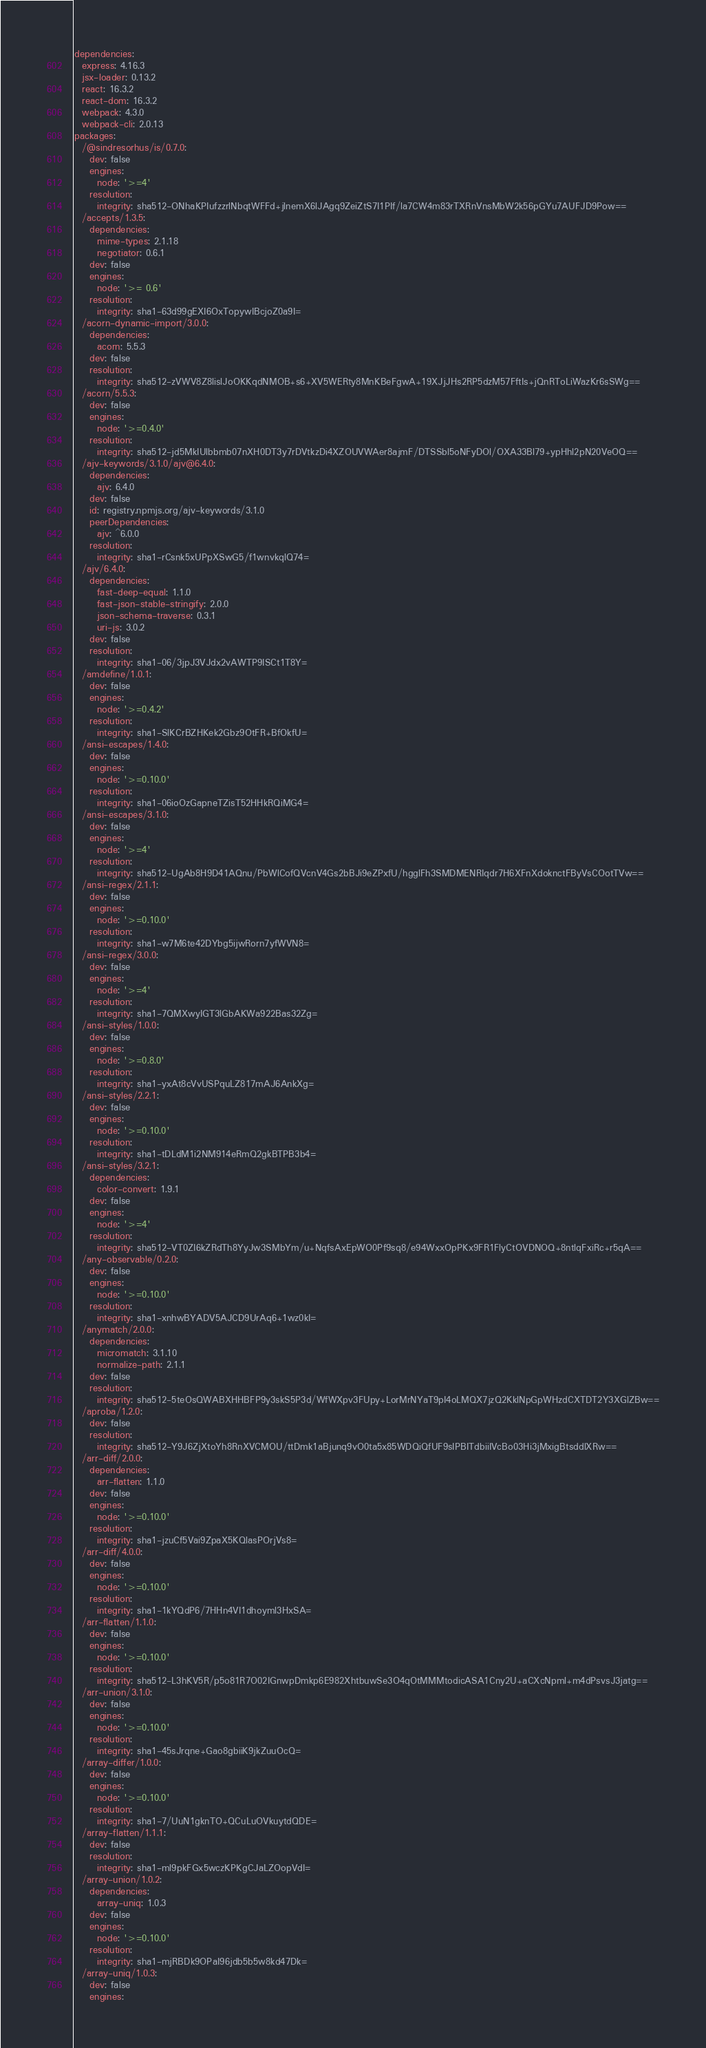<code> <loc_0><loc_0><loc_500><loc_500><_YAML_>dependencies:
  express: 4.16.3
  jsx-loader: 0.13.2
  react: 16.3.2
  react-dom: 16.3.2
  webpack: 4.3.0
  webpack-cli: 2.0.13
packages:
  /@sindresorhus/is/0.7.0:
    dev: false
    engines:
      node: '>=4'
    resolution:
      integrity: sha512-ONhaKPIufzzrlNbqtWFFd+jlnemX6lJAgq9ZeiZtS7I1PIf/la7CW4m83rTXRnVnsMbW2k56pGYu7AUFJD9Pow==
  /accepts/1.3.5:
    dependencies:
      mime-types: 2.1.18
      negotiator: 0.6.1
    dev: false
    engines:
      node: '>= 0.6'
    resolution:
      integrity: sha1-63d99gEXI6OxTopywIBcjoZ0a9I=
  /acorn-dynamic-import/3.0.0:
    dependencies:
      acorn: 5.5.3
    dev: false
    resolution:
      integrity: sha512-zVWV8Z8lislJoOKKqdNMOB+s6+XV5WERty8MnKBeFgwA+19XJjJHs2RP5dzM57FftIs+jQnRToLiWazKr6sSWg==
  /acorn/5.5.3:
    dev: false
    engines:
      node: '>=0.4.0'
    resolution:
      integrity: sha512-jd5MkIUlbbmb07nXH0DT3y7rDVtkzDi4XZOUVWAer8ajmF/DTSSbl5oNFyDOl/OXA33Bl79+ypHhl2pN20VeOQ==
  /ajv-keywords/3.1.0/ajv@6.4.0:
    dependencies:
      ajv: 6.4.0
    dev: false
    id: registry.npmjs.org/ajv-keywords/3.1.0
    peerDependencies:
      ajv: ^6.0.0
    resolution:
      integrity: sha1-rCsnk5xUPpXSwG5/f1wnvkqlQ74=
  /ajv/6.4.0:
    dependencies:
      fast-deep-equal: 1.1.0
      fast-json-stable-stringify: 2.0.0
      json-schema-traverse: 0.3.1
      uri-js: 3.0.2
    dev: false
    resolution:
      integrity: sha1-06/3jpJ3VJdx2vAWTP9ISCt1T8Y=
  /amdefine/1.0.1:
    dev: false
    engines:
      node: '>=0.4.2'
    resolution:
      integrity: sha1-SlKCrBZHKek2Gbz9OtFR+BfOkfU=
  /ansi-escapes/1.4.0:
    dev: false
    engines:
      node: '>=0.10.0'
    resolution:
      integrity: sha1-06ioOzGapneTZisT52HHkRQiMG4=
  /ansi-escapes/3.1.0:
    dev: false
    engines:
      node: '>=4'
    resolution:
      integrity: sha512-UgAb8H9D41AQnu/PbWlCofQVcnV4Gs2bBJi9eZPxfU/hgglFh3SMDMENRIqdr7H6XFnXdoknctFByVsCOotTVw==
  /ansi-regex/2.1.1:
    dev: false
    engines:
      node: '>=0.10.0'
    resolution:
      integrity: sha1-w7M6te42DYbg5ijwRorn7yfWVN8=
  /ansi-regex/3.0.0:
    dev: false
    engines:
      node: '>=4'
    resolution:
      integrity: sha1-7QMXwyIGT3lGbAKWa922Bas32Zg=
  /ansi-styles/1.0.0:
    dev: false
    engines:
      node: '>=0.8.0'
    resolution:
      integrity: sha1-yxAt8cVvUSPquLZ817mAJ6AnkXg=
  /ansi-styles/2.2.1:
    dev: false
    engines:
      node: '>=0.10.0'
    resolution:
      integrity: sha1-tDLdM1i2NM914eRmQ2gkBTPB3b4=
  /ansi-styles/3.2.1:
    dependencies:
      color-convert: 1.9.1
    dev: false
    engines:
      node: '>=4'
    resolution:
      integrity: sha512-VT0ZI6kZRdTh8YyJw3SMbYm/u+NqfsAxEpWO0Pf9sq8/e94WxxOpPKx9FR1FlyCtOVDNOQ+8ntlqFxiRc+r5qA==
  /any-observable/0.2.0:
    dev: false
    engines:
      node: '>=0.10.0'
    resolution:
      integrity: sha1-xnhwBYADV5AJCD9UrAq6+1wz0kI=
  /anymatch/2.0.0:
    dependencies:
      micromatch: 3.1.10
      normalize-path: 2.1.1
    dev: false
    resolution:
      integrity: sha512-5teOsQWABXHHBFP9y3skS5P3d/WfWXpv3FUpy+LorMrNYaT9pI4oLMQX7jzQ2KklNpGpWHzdCXTDT2Y3XGlZBw==
  /aproba/1.2.0:
    dev: false
    resolution:
      integrity: sha512-Y9J6ZjXtoYh8RnXVCMOU/ttDmk1aBjunq9vO0ta5x85WDQiQfUF9sIPBITdbiiIVcBo03Hi3jMxigBtsddlXRw==
  /arr-diff/2.0.0:
    dependencies:
      arr-flatten: 1.1.0
    dev: false
    engines:
      node: '>=0.10.0'
    resolution:
      integrity: sha1-jzuCf5Vai9ZpaX5KQlasPOrjVs8=
  /arr-diff/4.0.0:
    dev: false
    engines:
      node: '>=0.10.0'
    resolution:
      integrity: sha1-1kYQdP6/7HHn4VI1dhoyml3HxSA=
  /arr-flatten/1.1.0:
    dev: false
    engines:
      node: '>=0.10.0'
    resolution:
      integrity: sha512-L3hKV5R/p5o81R7O02IGnwpDmkp6E982XhtbuwSe3O4qOtMMMtodicASA1Cny2U+aCXcNpml+m4dPsvsJ3jatg==
  /arr-union/3.1.0:
    dev: false
    engines:
      node: '>=0.10.0'
    resolution:
      integrity: sha1-45sJrqne+Gao8gbiiK9jkZuuOcQ=
  /array-differ/1.0.0:
    dev: false
    engines:
      node: '>=0.10.0'
    resolution:
      integrity: sha1-7/UuN1gknTO+QCuLuOVkuytdQDE=
  /array-flatten/1.1.1:
    dev: false
    resolution:
      integrity: sha1-ml9pkFGx5wczKPKgCJaLZOopVdI=
  /array-union/1.0.2:
    dependencies:
      array-uniq: 1.0.3
    dev: false
    engines:
      node: '>=0.10.0'
    resolution:
      integrity: sha1-mjRBDk9OPaI96jdb5b5w8kd47Dk=
  /array-uniq/1.0.3:
    dev: false
    engines:</code> 